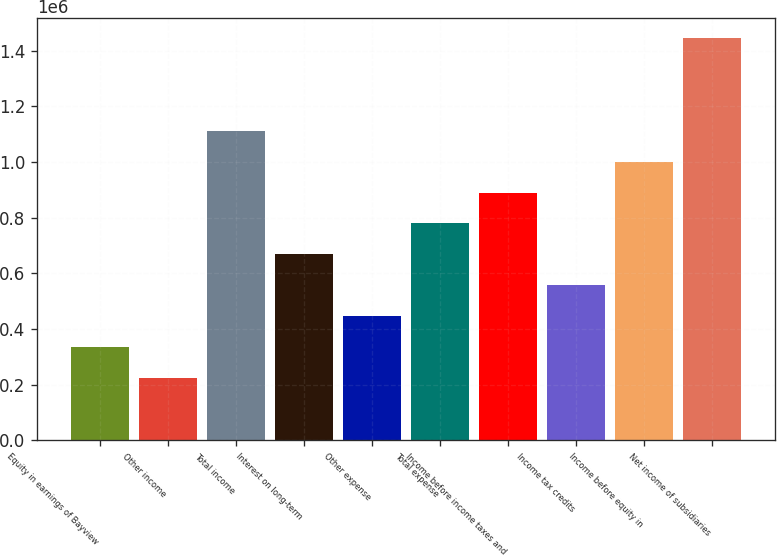Convert chart to OTSL. <chart><loc_0><loc_0><loc_500><loc_500><bar_chart><fcel>Equity in earnings of Bayview<fcel>Other income<fcel>Total income<fcel>Interest on long-term<fcel>Other expense<fcel>Total expense<fcel>Income before income taxes and<fcel>Income tax credits<fcel>Income before equity in<fcel>Net income of subsidiaries<nl><fcel>333860<fcel>222576<fcel>1.11285e+06<fcel>667713<fcel>445145<fcel>778998<fcel>890282<fcel>556429<fcel>1.00157e+06<fcel>1.4467e+06<nl></chart> 